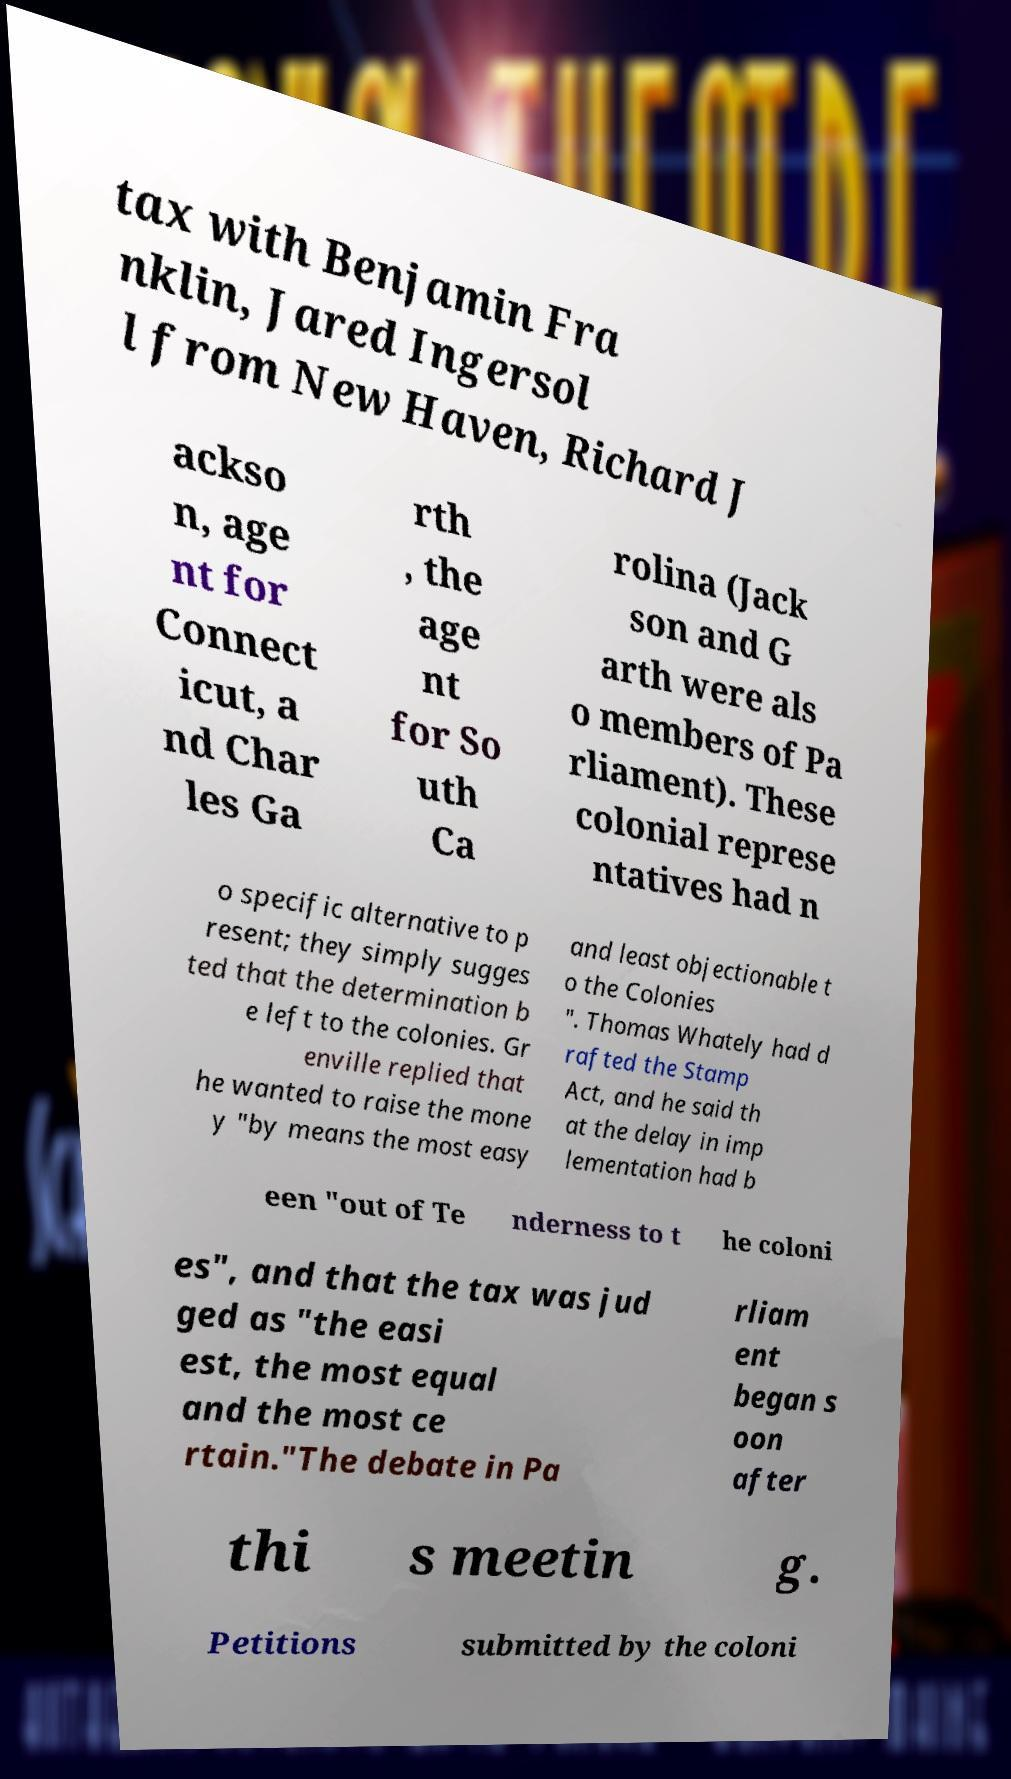Can you read and provide the text displayed in the image?This photo seems to have some interesting text. Can you extract and type it out for me? tax with Benjamin Fra nklin, Jared Ingersol l from New Haven, Richard J ackso n, age nt for Connect icut, a nd Char les Ga rth , the age nt for So uth Ca rolina (Jack son and G arth were als o members of Pa rliament). These colonial represe ntatives had n o specific alternative to p resent; they simply sugges ted that the determination b e left to the colonies. Gr enville replied that he wanted to raise the mone y "by means the most easy and least objectionable t o the Colonies ". Thomas Whately had d rafted the Stamp Act, and he said th at the delay in imp lementation had b een "out of Te nderness to t he coloni es", and that the tax was jud ged as "the easi est, the most equal and the most ce rtain."The debate in Pa rliam ent began s oon after thi s meetin g. Petitions submitted by the coloni 